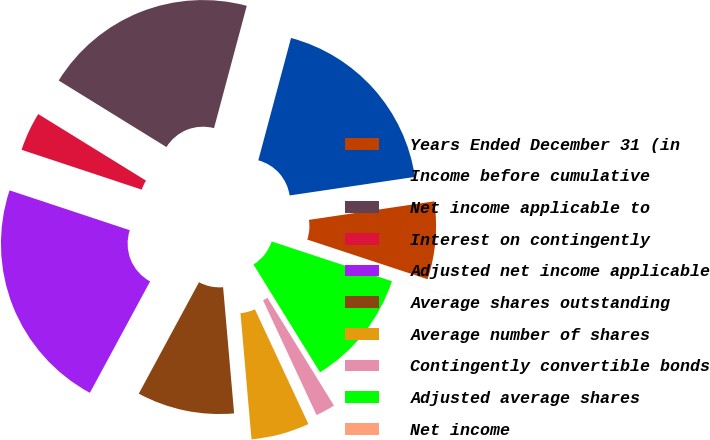Convert chart to OTSL. <chart><loc_0><loc_0><loc_500><loc_500><pie_chart><fcel>Years Ended December 31 (in<fcel>Income before cumulative<fcel>Net income applicable to<fcel>Interest on contingently<fcel>Adjusted net income applicable<fcel>Average shares outstanding<fcel>Average number of shares<fcel>Contingently convertible bonds<fcel>Adjusted average shares<fcel>Net income<nl><fcel>7.41%<fcel>18.5%<fcel>20.36%<fcel>3.71%<fcel>22.21%<fcel>9.27%<fcel>5.56%<fcel>1.86%<fcel>11.12%<fcel>0.01%<nl></chart> 